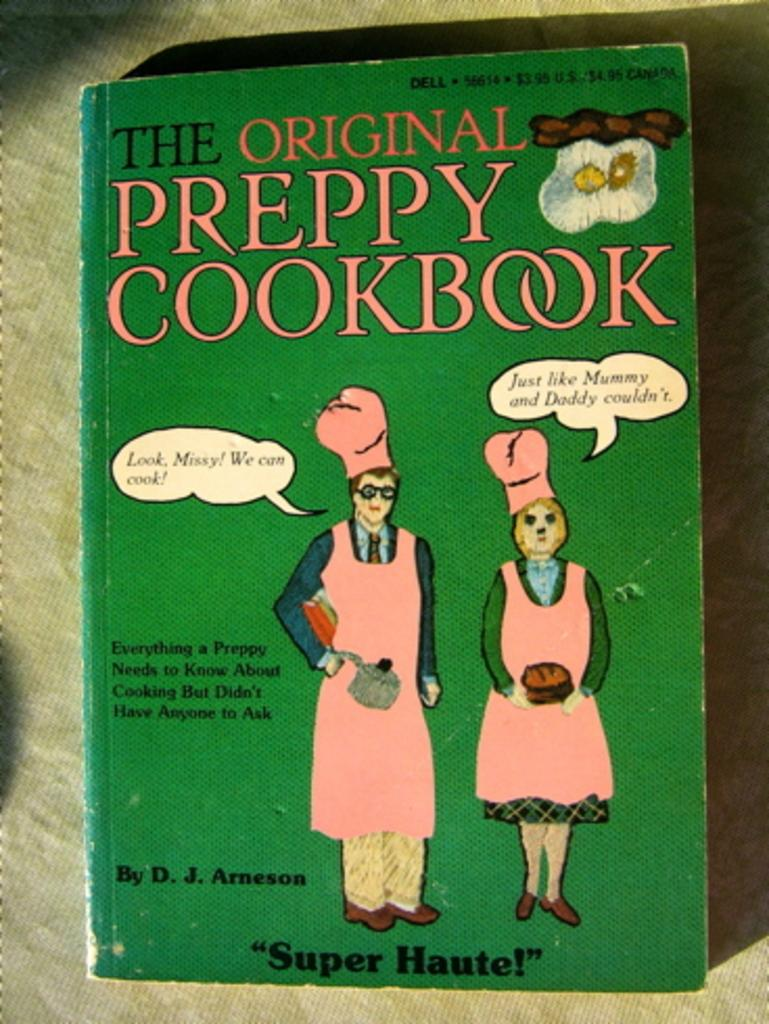<image>
Give a short and clear explanation of the subsequent image. A green book cover called "The Original Preppy Cookbook. 